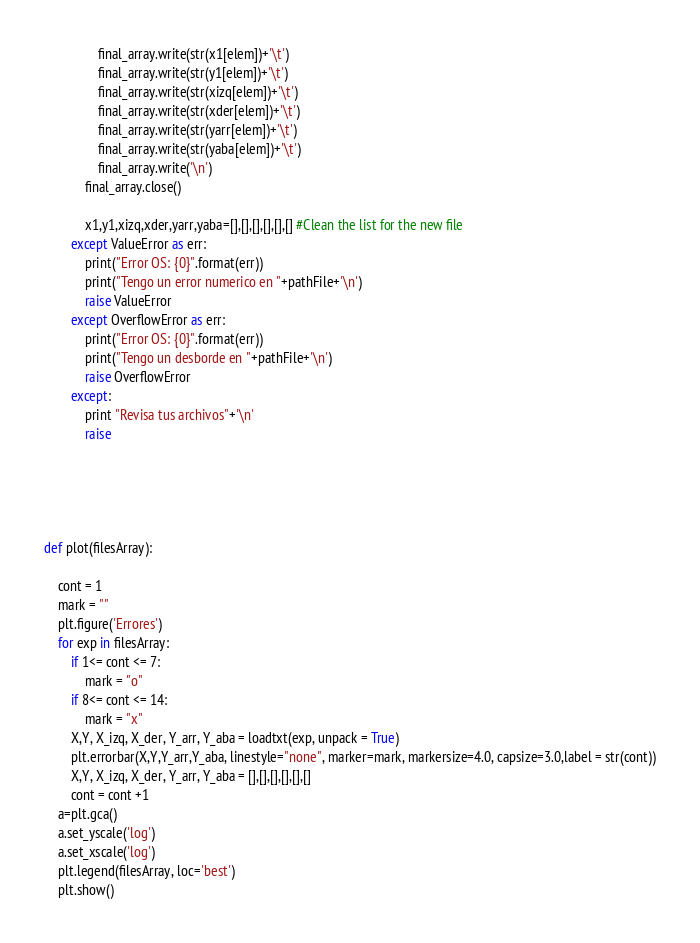Convert code to text. <code><loc_0><loc_0><loc_500><loc_500><_Python_>                final_array.write(str(x1[elem])+'\t')
                final_array.write(str(y1[elem])+'\t')
                final_array.write(str(xizq[elem])+'\t')
                final_array.write(str(xder[elem])+'\t')
                final_array.write(str(yarr[elem])+'\t')
                final_array.write(str(yaba[elem])+'\t')
                final_array.write('\n')
            final_array.close()

            x1,y1,xizq,xder,yarr,yaba=[],[],[],[],[],[] #Clean the list for the new file
        except ValueError as err:
            print("Error OS: {0}".format(err))
            print("Tengo un error numerico en "+pathFile+'\n')
            raise ValueError
        except OverflowError as err:
            print("Error OS: {0}".format(err))
            print("Tengo un desborde en "+pathFile+'\n')
            raise OverflowError
        except:
            print "Revisa tus archivos"+'\n'
            raise
            


            

def plot(filesArray):

    cont = 1
    mark = ""
    plt.figure('Errores')
    for exp in filesArray:
        if 1<= cont <= 7:
            mark = "o"
        if 8<= cont <= 14:
            mark = "x"
        X,Y, X_izq, X_der, Y_arr, Y_aba = loadtxt(exp, unpack = True)
        plt.errorbar(X,Y,Y_arr,Y_aba, linestyle="none", marker=mark, markersize=4.0, capsize=3.0,label = str(cont))
        X,Y, X_izq, X_der, Y_arr, Y_aba = [],[],[],[],[],[]
        cont = cont +1
    a=plt.gca()
    a.set_yscale('log')
    a.set_xscale('log')
    plt.legend(filesArray, loc='best')
    plt.show()

</code> 